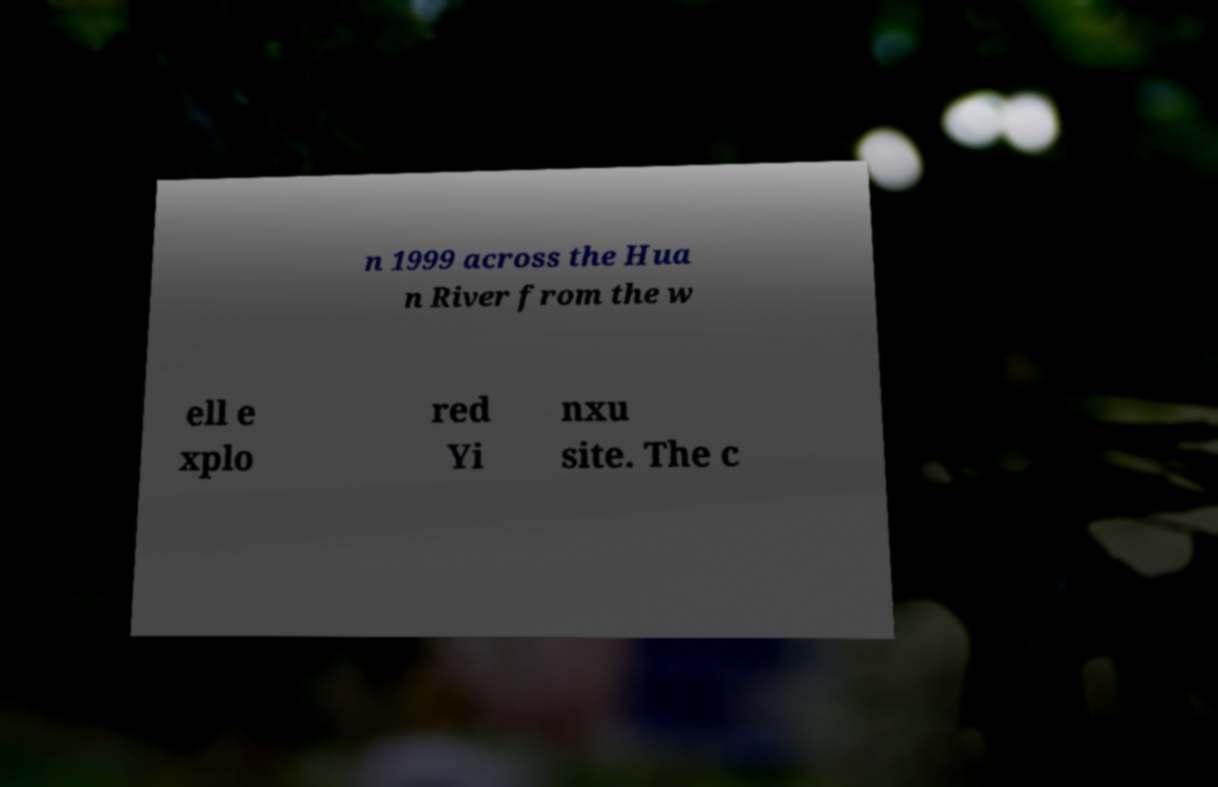Please read and relay the text visible in this image. What does it say? n 1999 across the Hua n River from the w ell e xplo red Yi nxu site. The c 